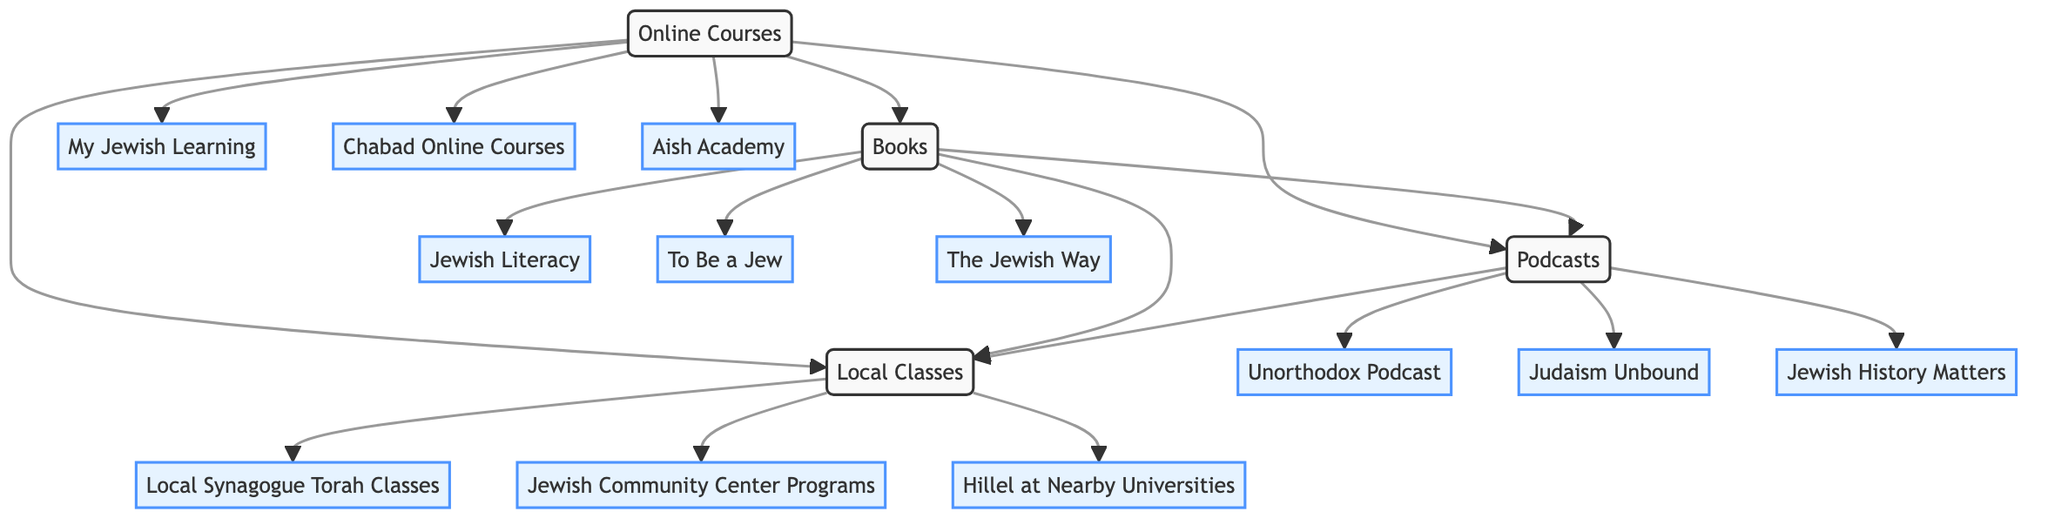What nodes are connected to Online Courses? The diagram shows that Online Courses connects to three nodes: Books, Podcasts, and Local Classes. This can be determined by following the outgoing edges from the Online Courses node to these three nodes.
Answer: Books, Podcasts, Local Classes How many resources are listed under Books? By inspecting the Books node, there are three specific resources listed: Jewish Literacy by Joseph Telushkin, To Be a Jew by Hayim Halevy Donin, and The Jewish Way by Irving Greenberg. Thus, the count is three.
Answer: 3 Which Podcasts are directly linked to Books? The Podcasts node connects directly to Books through an edge. The specific podcasts listed under this connection are Unorthodox Podcast, Judaism Unbound, and Jewish History Matters.
Answer: Unorthodox Podcast, Judaism Unbound, Jewish History Matters What is the relationship between Local Classes and Podcasts? The diagram indicates a direct connection (edge) from Local Classes to Podcasts, meaning there is interaction or correlation between these two categories, specifically, resources about Podcasts can also relate to Local Classes.
Answer: Connected How many edges are displayed in the diagram? The diagram includes a total of six edges, which can be counted by examining the connections (arrows) between the nodes. Each connection represents an edge in the network diagram.
Answer: 6 Which resource under Online Courses has the URL https://www.myjewishlearning.com? Looking specifically at the resources listed under the Online Courses node, the resource with that URL is My Jewish Learning, as it is one of the educational platforms offered in that category.
Answer: My Jewish Learning Are there any local class resources that focus on Torah? Yes, the diagram states that the Local Synagogue Torah Classes are specifically mentioned as a resource under the Local Classes node, indicating a focus on Torah education.
Answer: Yes What is the common link between all nodes? Each of the nodes (Online Courses, Books, Podcasts, Local Classes) is interconnected, meaning that they all provide resources related to Jewish education. This relationship is depicted through multiple edges that connect each node to at least one other.
Answer: Interconnected 